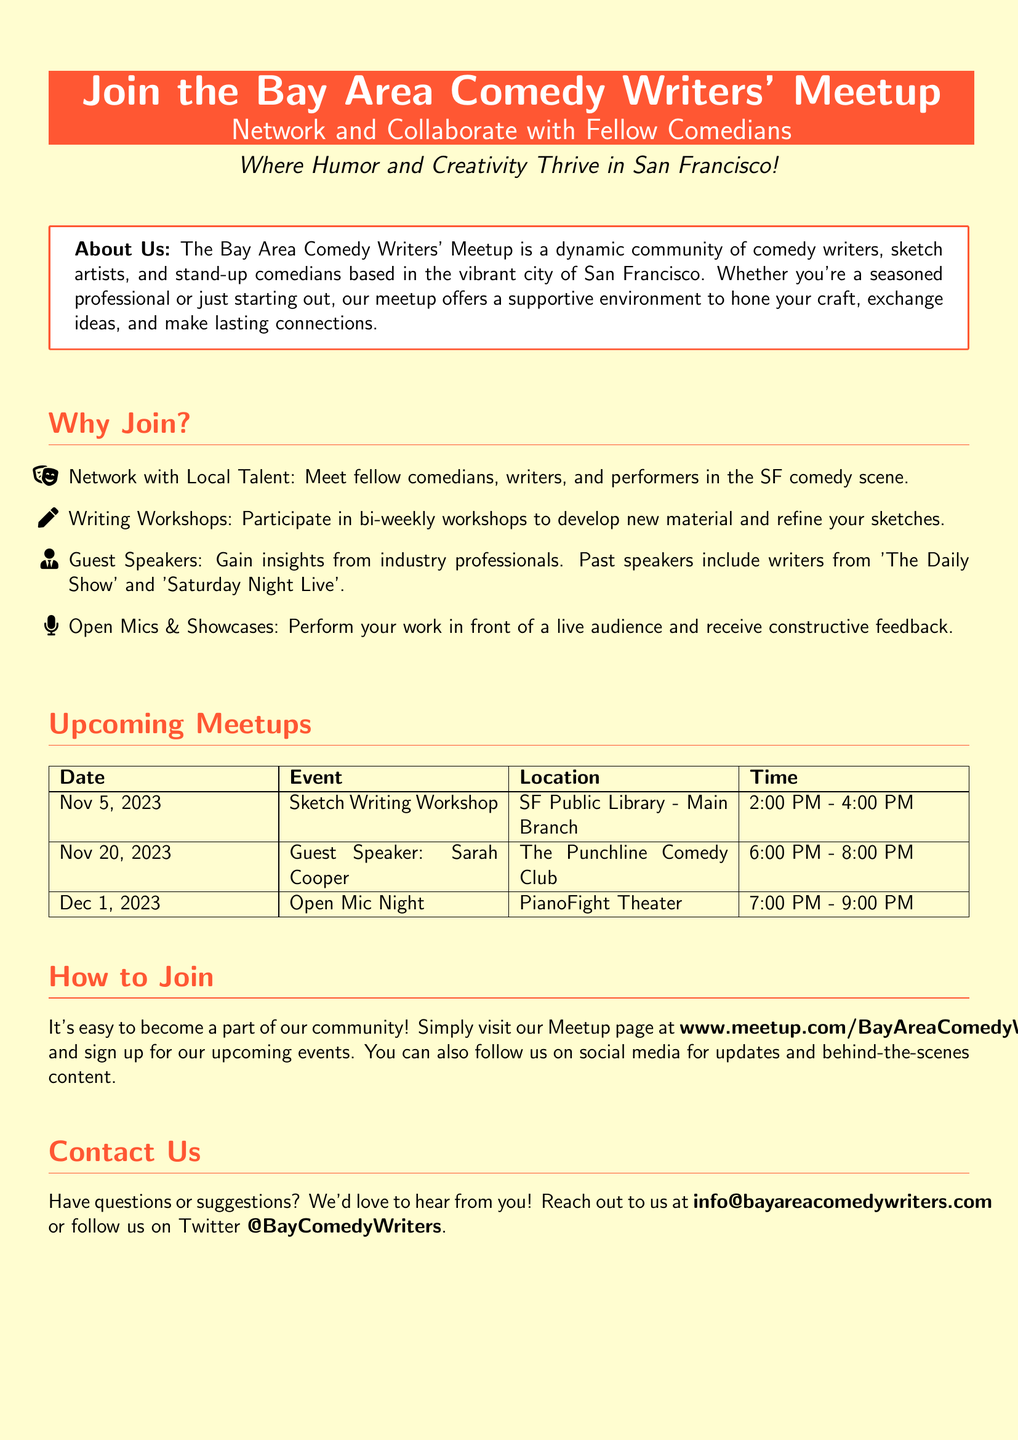What is the name of the meetup? The meetup is specifically called the Bay Area Comedy Writers' Meetup.
Answer: Bay Area Comedy Writers' Meetup Where is the first upcoming event taking place? The first upcoming event is a Sketch Writing Workshop at the SF Public Library - Main Branch.
Answer: SF Public Library - Main Branch What date is the Guest Speaker event scheduled? The Guest Speaker event featuring Sarah Cooper is scheduled for November 20, 2023.
Answer: Nov 20, 2023 How long does the Open Mic Night last? The Open Mic Night is scheduled for 2 hours, from 7:00 PM to 9:00 PM.
Answer: 2 hours What can attendees gain from the guest speakers? Attendees can gain insights from industry professionals, including writers from notable shows such as 'The Daily Show' and 'Saturday Night Live'.
Answer: Insights from industry professionals How often do writing workshops take place? The writing workshops occur bi-weekly.
Answer: Bi-weekly What is the website to join the meetup? The website where individuals can sign up for the meetup is www.meetup.com/BayAreaComedyWriters.
Answer: www.meetup.com/BayAreaComedyWriters What is the email contact for the meetup? The contact email for the meetup is info@bayareacomedywriters.com.
Answer: info@bayareacomedywriters.com 